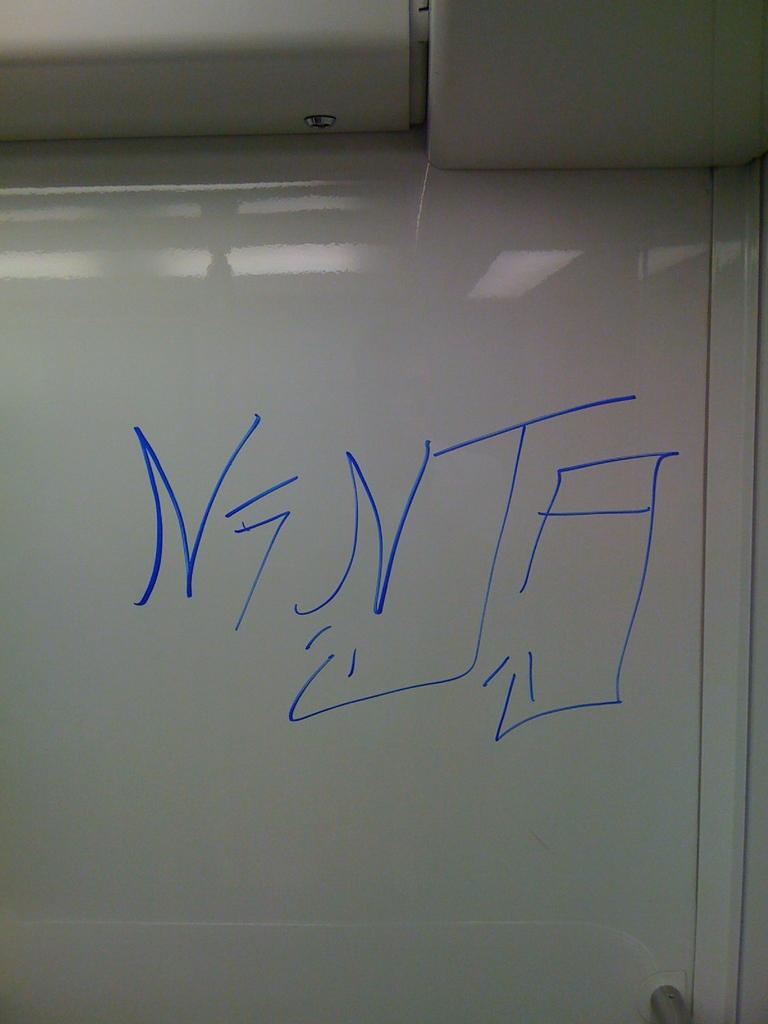<image>
Provide a brief description of the given image. A classroom white board with large blue lettering with the writing "Nenta." 